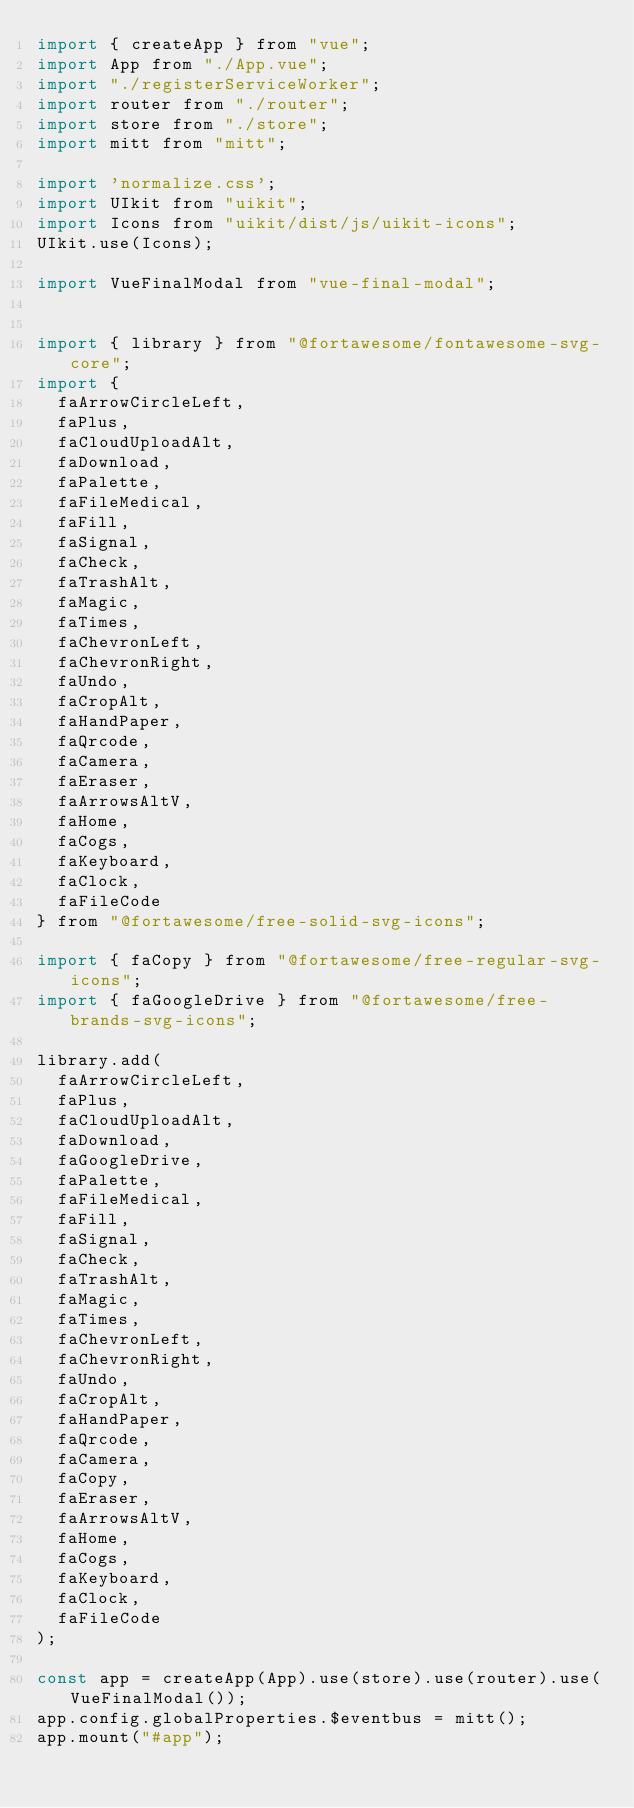Convert code to text. <code><loc_0><loc_0><loc_500><loc_500><_JavaScript_>import { createApp } from "vue";
import App from "./App.vue";
import "./registerServiceWorker";
import router from "./router";
import store from "./store";
import mitt from "mitt";

import 'normalize.css';
import UIkit from "uikit";
import Icons from "uikit/dist/js/uikit-icons";
UIkit.use(Icons);

import VueFinalModal from "vue-final-modal";


import { library } from "@fortawesome/fontawesome-svg-core";
import {
  faArrowCircleLeft,
  faPlus,
  faCloudUploadAlt,
  faDownload,
  faPalette,
  faFileMedical,
  faFill,
  faSignal,
  faCheck,
  faTrashAlt,
  faMagic,
  faTimes,
  faChevronLeft,
  faChevronRight,
  faUndo,
  faCropAlt,
  faHandPaper,
  faQrcode,
  faCamera,
  faEraser,
  faArrowsAltV,
  faHome,
  faCogs,
  faKeyboard,
  faClock,
  faFileCode
} from "@fortawesome/free-solid-svg-icons";

import { faCopy } from "@fortawesome/free-regular-svg-icons";
import { faGoogleDrive } from "@fortawesome/free-brands-svg-icons";

library.add(
  faArrowCircleLeft,
  faPlus,
  faCloudUploadAlt,
  faDownload,
  faGoogleDrive,
  faPalette,
  faFileMedical,
  faFill,
  faSignal,
  faCheck,
  faTrashAlt,
  faMagic,
  faTimes,
  faChevronLeft,
  faChevronRight,
  faUndo,
  faCropAlt,
  faHandPaper,
  faQrcode,
  faCamera,
  faCopy,
  faEraser,
  faArrowsAltV,
  faHome,
  faCogs,
  faKeyboard,
  faClock,
  faFileCode
);

const app = createApp(App).use(store).use(router).use(VueFinalModal());
app.config.globalProperties.$eventbus = mitt();
app.mount("#app");
</code> 